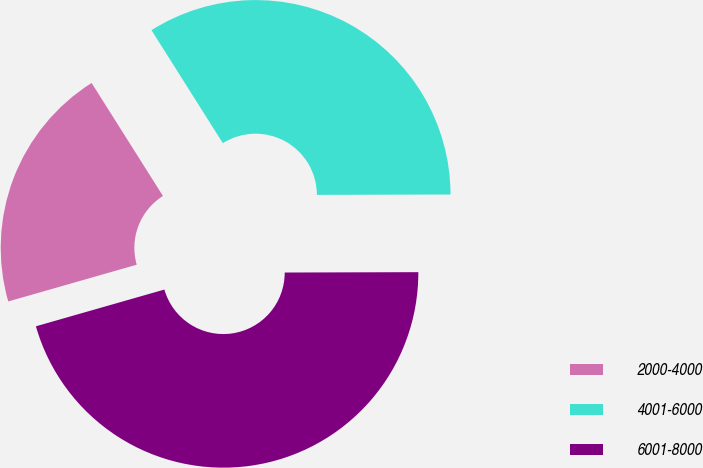Convert chart to OTSL. <chart><loc_0><loc_0><loc_500><loc_500><pie_chart><fcel>2000-4000<fcel>4001-6000<fcel>6001-8000<nl><fcel>20.47%<fcel>33.92%<fcel>45.61%<nl></chart> 